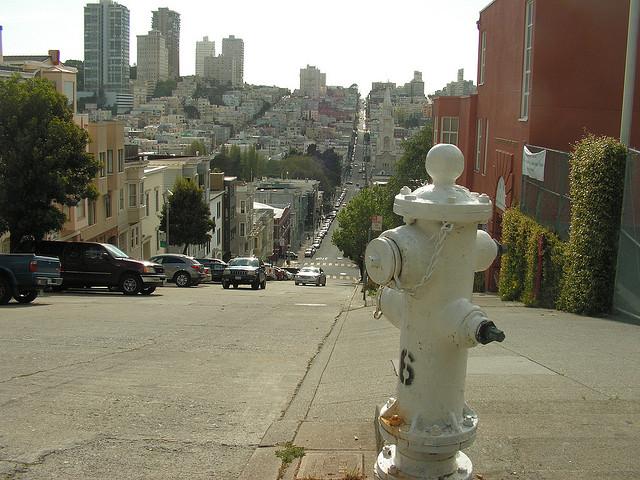Is this a busy city?
Write a very short answer. Yes. Is there a steep hill running through town?
Quick response, please. Yes. What is the white thing with the number 6 on it?
Quick response, please. Fire hydrant. 